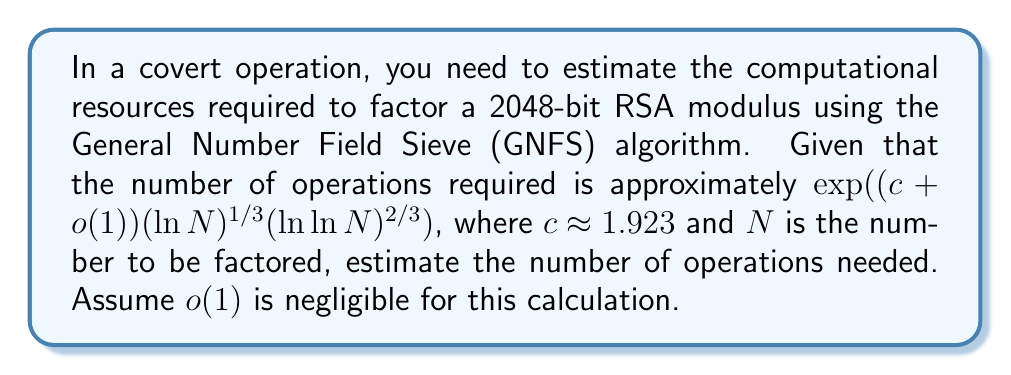Solve this math problem. Let's approach this step-by-step:

1) The RSA modulus is 2048 bits, so $N = 2^{2048}$.

2) We need to calculate $(\ln N)^{1/3}(\ln \ln N)^{2/3}$.

3) First, let's calculate $\ln N$:
   $\ln N = \ln(2^{2048}) = 2048 \ln 2 \approx 1419.97$

4) Now, let's calculate $\ln \ln N$:
   $\ln \ln N = \ln(1419.97) \approx 7.26$

5) Now we can calculate $(\ln N)^{1/3}(\ln \ln N)^{2/3}$:
   $(1419.97)^{1/3} \cdot (7.26)^{2/3} \approx 11.28 \cdot 3.83 \approx 43.20$

6) The number of operations is $\exp(1.923 \cdot 43.20)$

7) Calculate this:
   $\exp(83.07) \approx 1.23 \times 10^{36}$

Therefore, approximately $1.23 \times 10^{36}$ operations are required.
Answer: $1.23 \times 10^{36}$ operations 